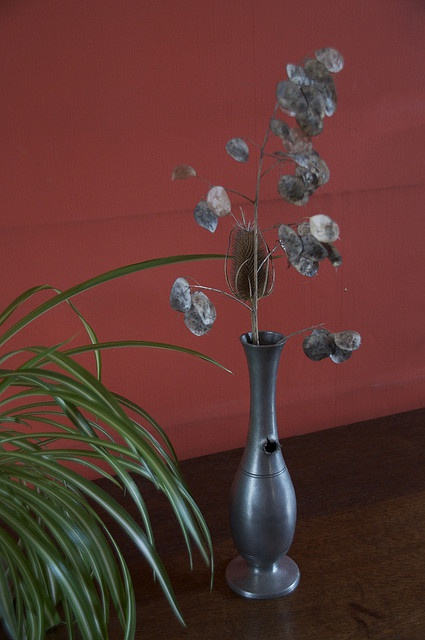Describe the objects in this image and their specific colors. I can see a vase in maroon, black, gray, and darkblue tones in this image. 